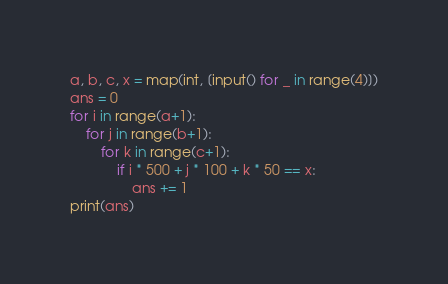Convert code to text. <code><loc_0><loc_0><loc_500><loc_500><_Python_>a, b, c, x = map(int, [input() for _ in range(4)])
ans = 0
for i in range(a+1):
    for j in range(b+1):
        for k in range(c+1):
            if i * 500 + j * 100 + k * 50 == x:
                ans += 1
print(ans)</code> 